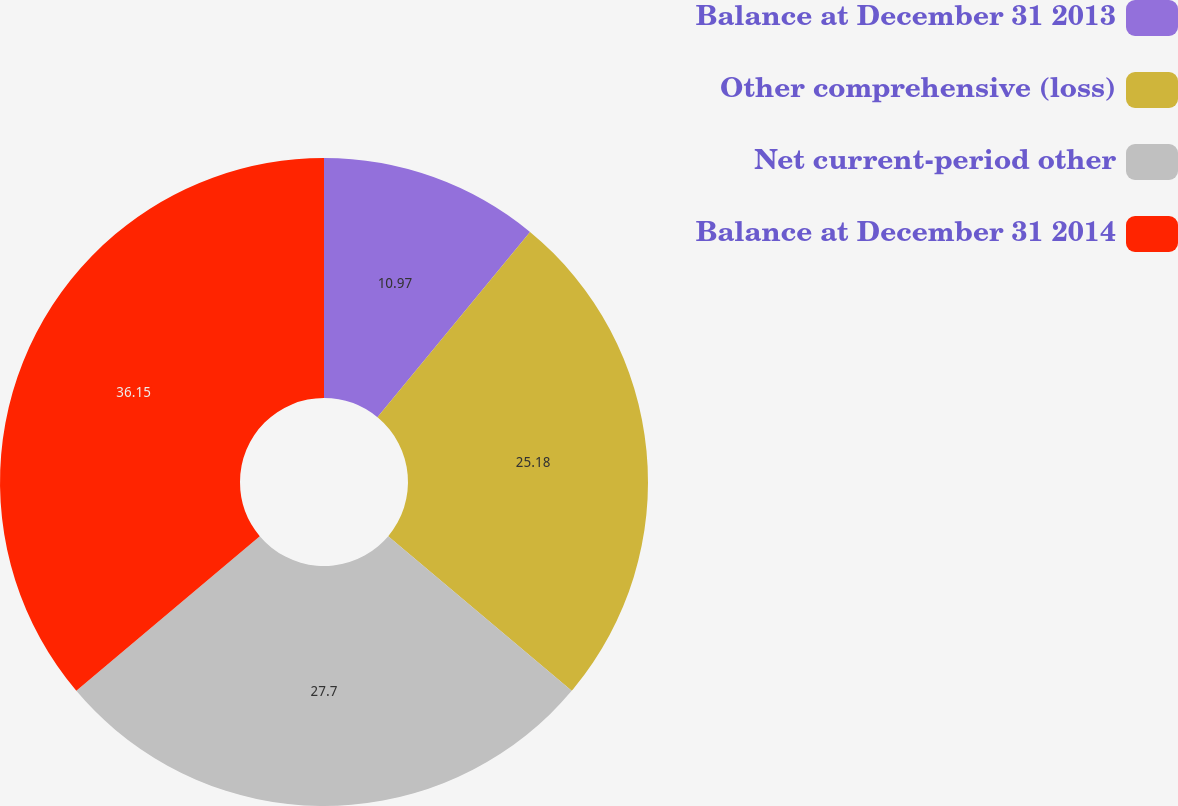Convert chart. <chart><loc_0><loc_0><loc_500><loc_500><pie_chart><fcel>Balance at December 31 2013<fcel>Other comprehensive (loss)<fcel>Net current-period other<fcel>Balance at December 31 2014<nl><fcel>10.97%<fcel>25.18%<fcel>27.7%<fcel>36.15%<nl></chart> 